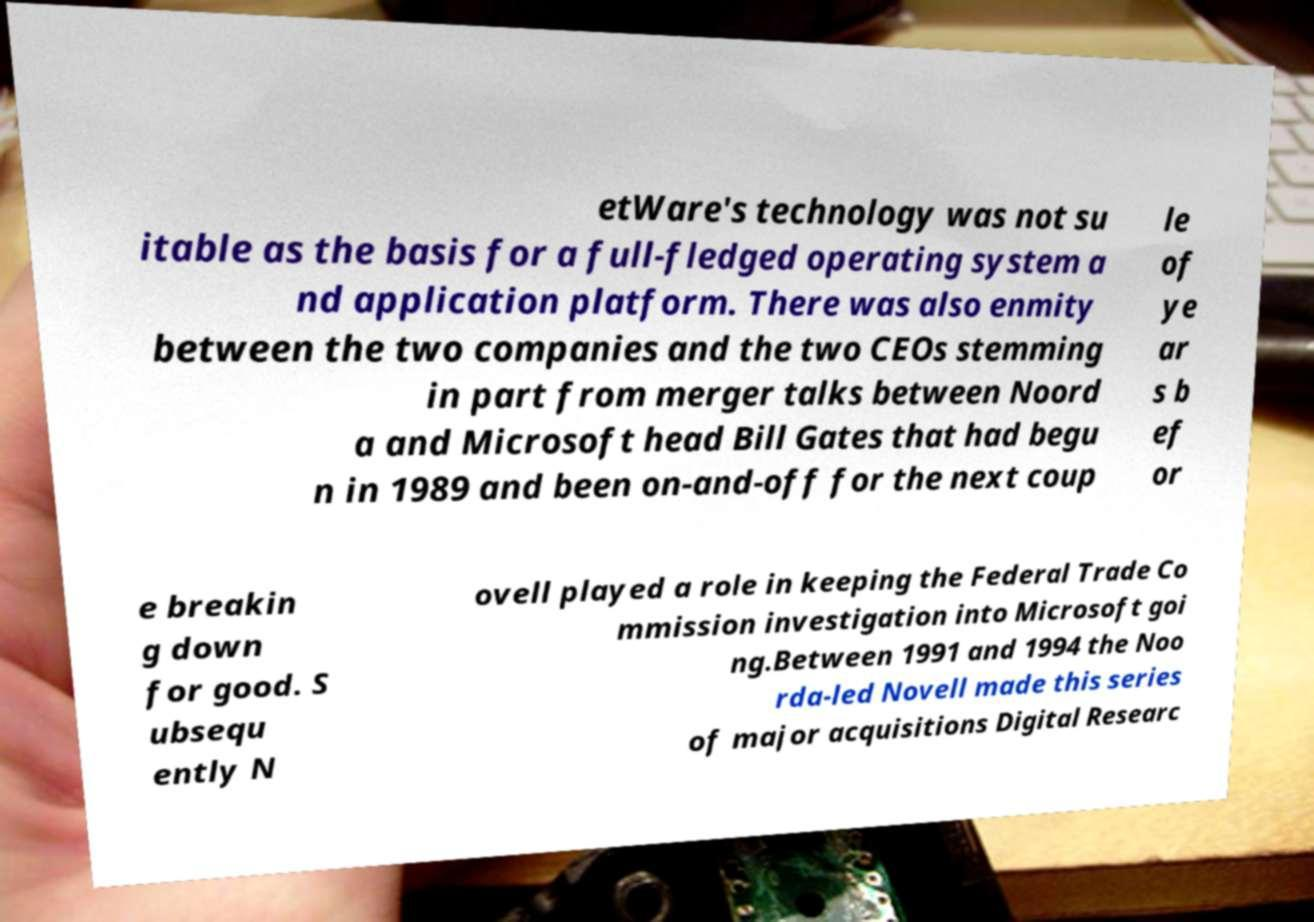Can you read and provide the text displayed in the image?This photo seems to have some interesting text. Can you extract and type it out for me? etWare's technology was not su itable as the basis for a full-fledged operating system a nd application platform. There was also enmity between the two companies and the two CEOs stemming in part from merger talks between Noord a and Microsoft head Bill Gates that had begu n in 1989 and been on-and-off for the next coup le of ye ar s b ef or e breakin g down for good. S ubsequ ently N ovell played a role in keeping the Federal Trade Co mmission investigation into Microsoft goi ng.Between 1991 and 1994 the Noo rda-led Novell made this series of major acquisitions Digital Researc 